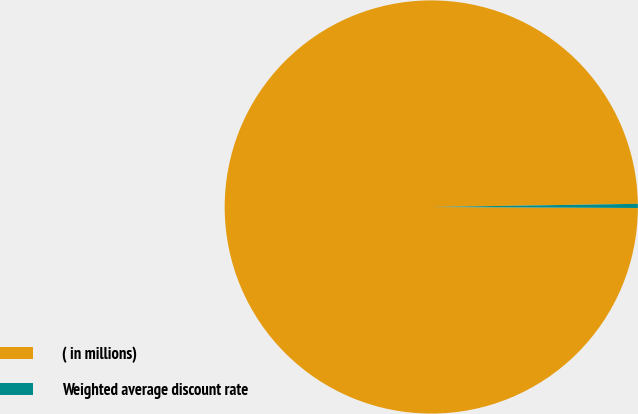<chart> <loc_0><loc_0><loc_500><loc_500><pie_chart><fcel>( in millions)<fcel>Weighted average discount rate<nl><fcel>99.68%<fcel>0.32%<nl></chart> 